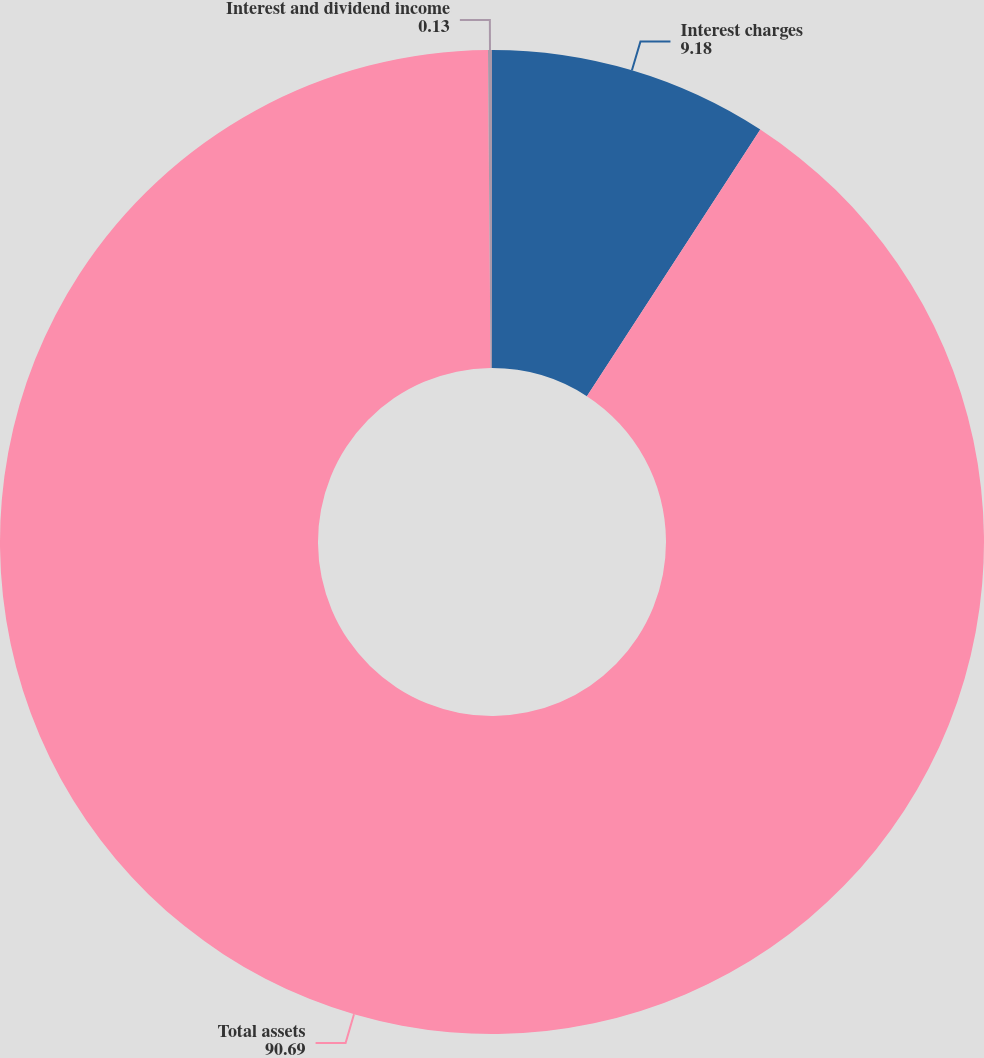Convert chart. <chart><loc_0><loc_0><loc_500><loc_500><pie_chart><fcel>Interest charges<fcel>Total assets<fcel>Interest and dividend income<nl><fcel>9.18%<fcel>90.69%<fcel>0.13%<nl></chart> 